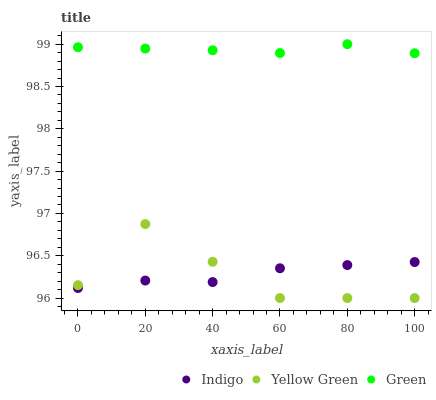Does Yellow Green have the minimum area under the curve?
Answer yes or no. Yes. Does Green have the maximum area under the curve?
Answer yes or no. Yes. Does Indigo have the minimum area under the curve?
Answer yes or no. No. Does Indigo have the maximum area under the curve?
Answer yes or no. No. Is Green the smoothest?
Answer yes or no. Yes. Is Yellow Green the roughest?
Answer yes or no. Yes. Is Indigo the smoothest?
Answer yes or no. No. Is Indigo the roughest?
Answer yes or no. No. Does Yellow Green have the lowest value?
Answer yes or no. Yes. Does Indigo have the lowest value?
Answer yes or no. No. Does Green have the highest value?
Answer yes or no. Yes. Does Yellow Green have the highest value?
Answer yes or no. No. Is Yellow Green less than Green?
Answer yes or no. Yes. Is Green greater than Indigo?
Answer yes or no. Yes. Does Indigo intersect Yellow Green?
Answer yes or no. Yes. Is Indigo less than Yellow Green?
Answer yes or no. No. Is Indigo greater than Yellow Green?
Answer yes or no. No. Does Yellow Green intersect Green?
Answer yes or no. No. 